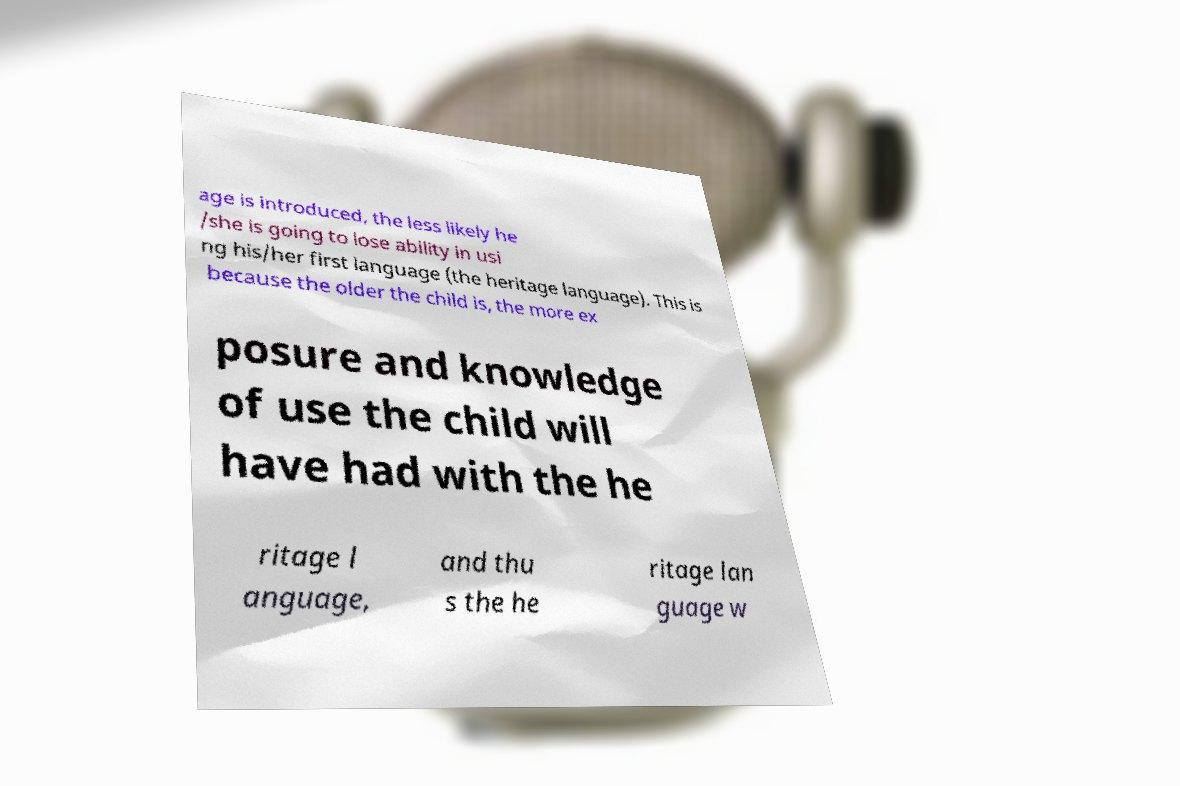Could you extract and type out the text from this image? age is introduced, the less likely he /she is going to lose ability in usi ng his/her first language (the heritage language). This is because the older the child is, the more ex posure and knowledge of use the child will have had with the he ritage l anguage, and thu s the he ritage lan guage w 